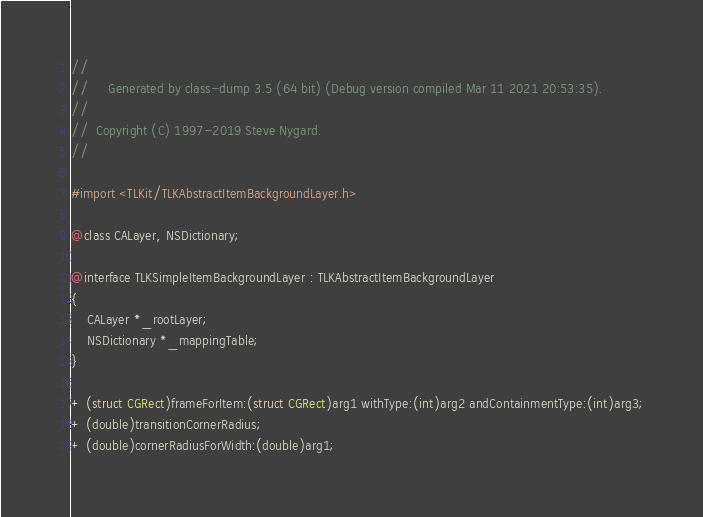Convert code to text. <code><loc_0><loc_0><loc_500><loc_500><_C_>//
//     Generated by class-dump 3.5 (64 bit) (Debug version compiled Mar 11 2021 20:53:35).
//
//  Copyright (C) 1997-2019 Steve Nygard.
//

#import <TLKit/TLKAbstractItemBackgroundLayer.h>

@class CALayer, NSDictionary;

@interface TLKSimpleItemBackgroundLayer : TLKAbstractItemBackgroundLayer
{
    CALayer *_rootLayer;
    NSDictionary *_mappingTable;
}

+ (struct CGRect)frameForItem:(struct CGRect)arg1 withType:(int)arg2 andContainmentType:(int)arg3;
+ (double)transitionCornerRadius;
+ (double)cornerRadiusForWidth:(double)arg1;</code> 